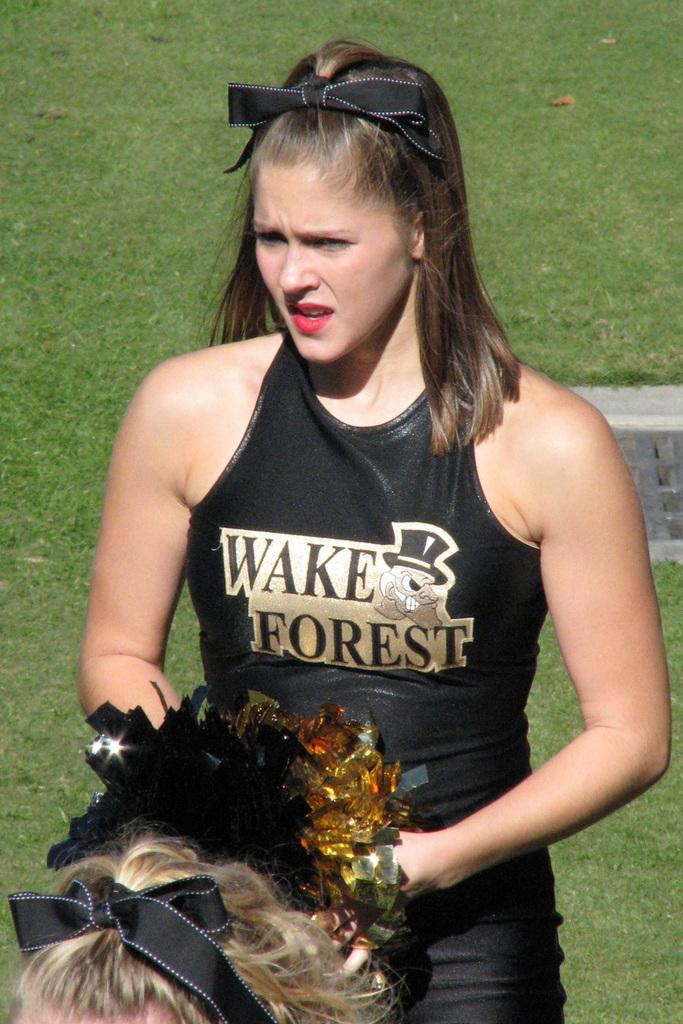Provide a one-sentence caption for the provided image. a person that is wearing a Wake Forest outfit on the field. 